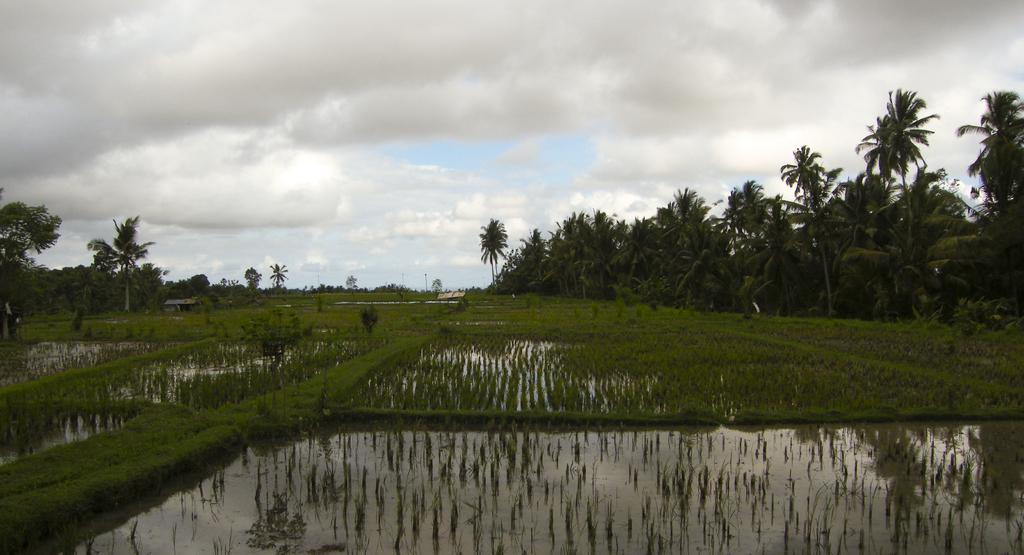What type of landscape is depicted in the image? The image features crop fields. Are there any structures visible in the image? Yes, there are houses in the image. What can be seen in the background of the image? There are trees in the background of the image. What is visible at the top of the image? The sky is visible at the top of the image. What is the condition of the sky in the image? Clouds are present in the sky. Where is the crayon located in the image? There is no crayon present in the image. What type of loss is depicted in the image? There is no loss depicted in the image; it features crop fields, houses, trees, and a sky with clouds. 